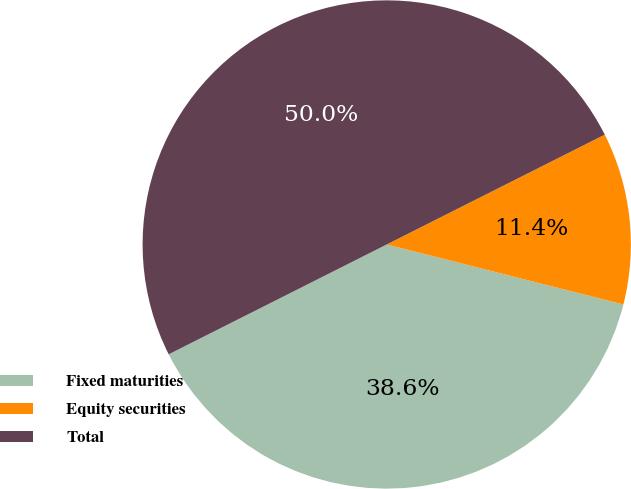Convert chart. <chart><loc_0><loc_0><loc_500><loc_500><pie_chart><fcel>Fixed maturities<fcel>Equity securities<fcel>Total<nl><fcel>38.62%<fcel>11.38%<fcel>50.0%<nl></chart> 